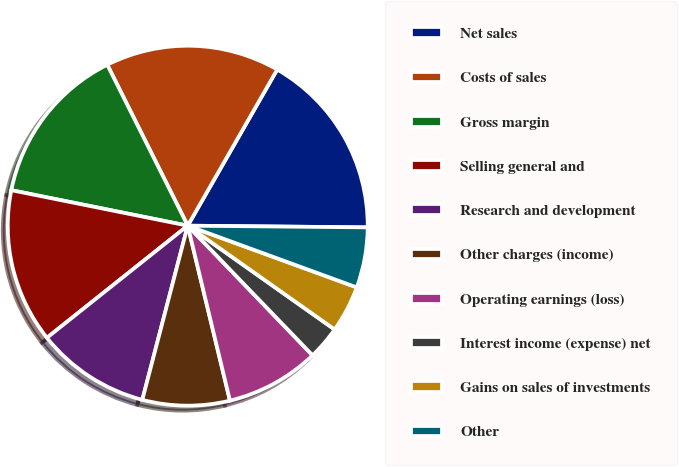Convert chart. <chart><loc_0><loc_0><loc_500><loc_500><pie_chart><fcel>Net sales<fcel>Costs of sales<fcel>Gross margin<fcel>Selling general and<fcel>Research and development<fcel>Other charges (income)<fcel>Operating earnings (loss)<fcel>Interest income (expense) net<fcel>Gains on sales of investments<fcel>Other<nl><fcel>16.87%<fcel>15.66%<fcel>14.46%<fcel>13.86%<fcel>10.24%<fcel>7.83%<fcel>8.43%<fcel>3.01%<fcel>4.22%<fcel>5.42%<nl></chart> 